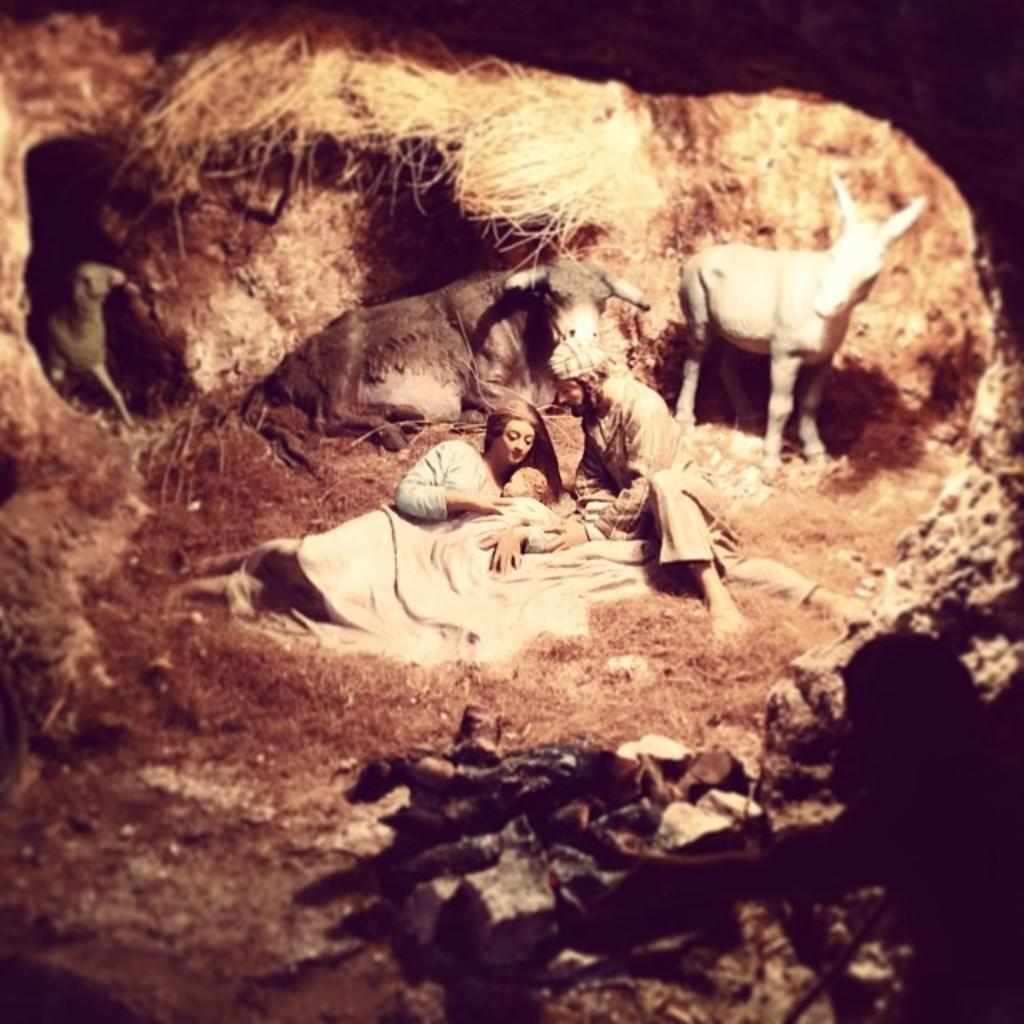What is the main subject in the center of the image? There is a man sitting in the center of the image. What other people can be seen in the image? There is a baby and a lady lying in the image. What can be seen in the background of the image? There are animals and grass visible in the background of the image. What type of lizards are crawling on the man's hands in the image? There are no lizards present in the image, and the man's hands are not visible. 